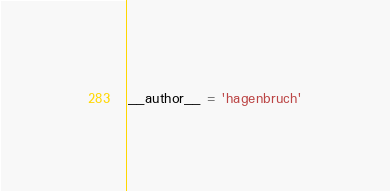Convert code to text. <code><loc_0><loc_0><loc_500><loc_500><_Python_>__author__ = 'hagenbruch'
</code> 